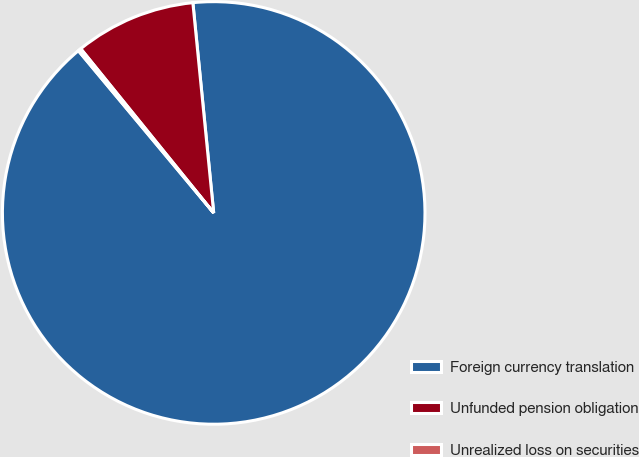Convert chart. <chart><loc_0><loc_0><loc_500><loc_500><pie_chart><fcel>Foreign currency translation<fcel>Unfunded pension obligation<fcel>Unrealized loss on securities<nl><fcel>90.5%<fcel>9.26%<fcel>0.23%<nl></chart> 